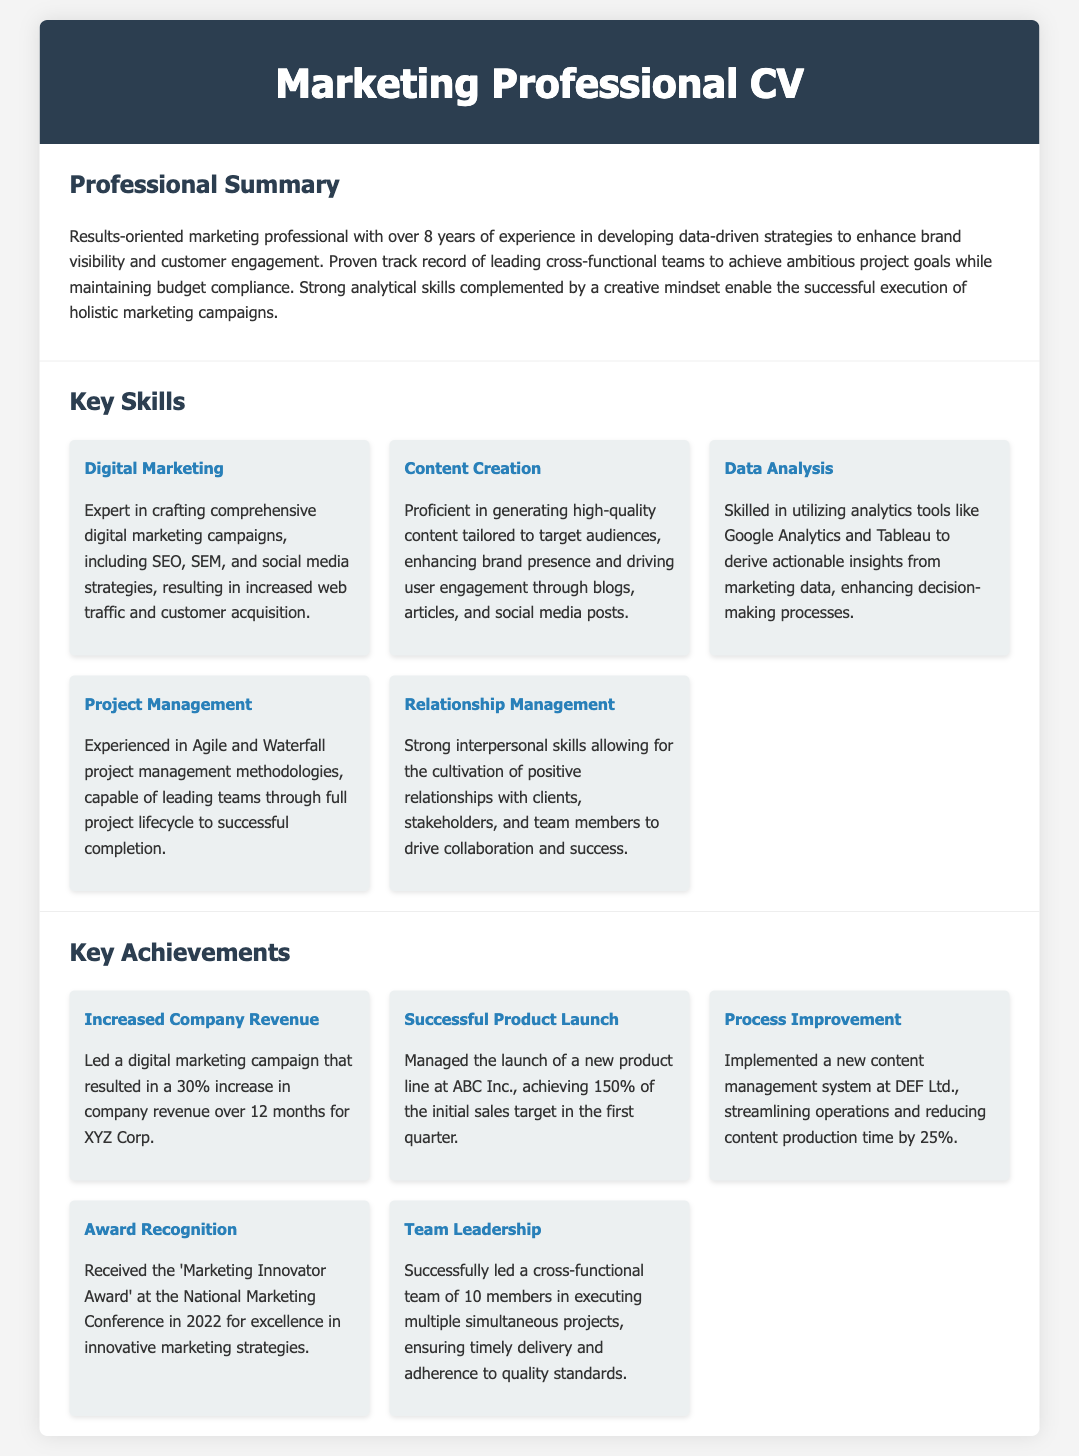What is the professional summary of the candidate? The professional summary highlights the candidate's experience and skills in marketing, emphasizing their results-oriented approach and ability to lead projects and teams.
Answer: Results-oriented marketing professional with over 8 years of experience in developing data-driven strategies to enhance brand visibility and customer engagement How many years of experience does the candidate have? The document states the total years of experience the candidate has in marketing.
Answer: 8 years What is one of the key skills related to project management? The document lists multiple skills, one of which relates directly to project management methodologies.
Answer: Agile and Waterfall project management methodologies Which company did the candidate achieve a 30% increase in revenue for? The achievement section mentions the specific company linked to that revenue increase in a digital marketing campaign.
Answer: XYZ Corp What award did the candidate receive? The document includes information about an award received for marketing excellence.
Answer: Marketing Innovator Award What percentage of the sales target did the candidate achieve during a product launch? The achievements mention the success of a product launch measured against initial sales targets.
Answer: 150% What is one of the candidate's analytical skills? The document specifically mentions which analytics tools the candidate is skilled in using for deriving insights.
Answer: Google Analytics and Tableau What does the candidate excel at in terms of relationship management? The document describes the candidate's interpersonal skills related to relationship management.
Answer: Cultivation of positive relationships 